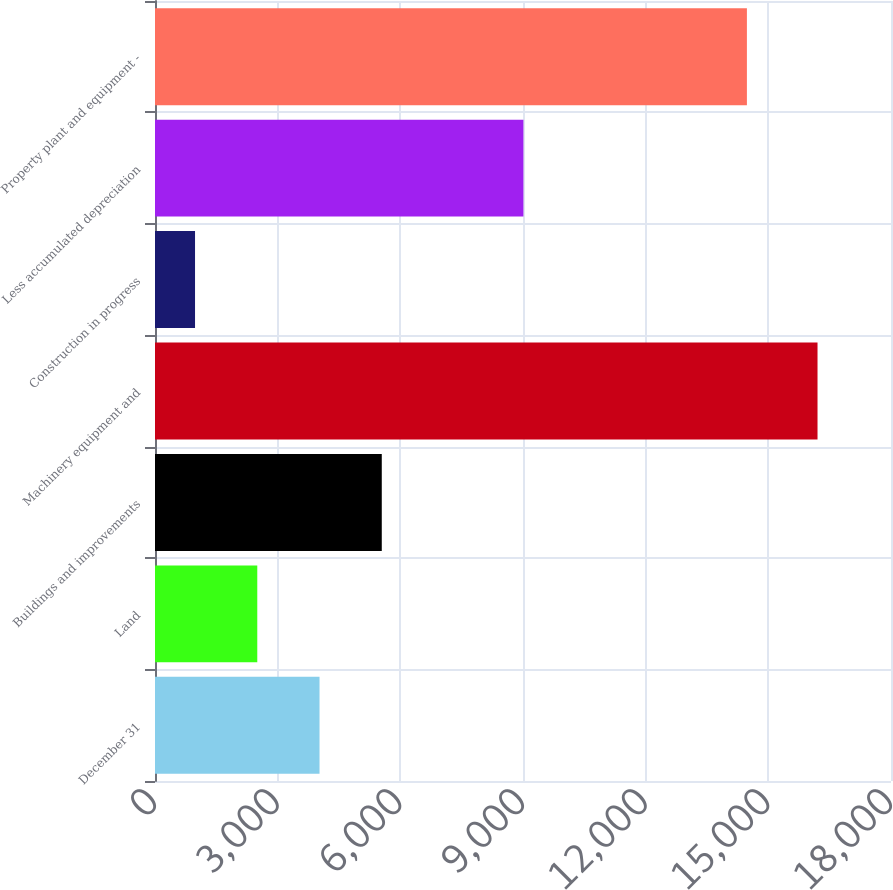Convert chart. <chart><loc_0><loc_0><loc_500><loc_500><bar_chart><fcel>December 31<fcel>Land<fcel>Buildings and improvements<fcel>Machinery equipment and<fcel>Construction in progress<fcel>Less accumulated depreciation<fcel>Property plant and equipment -<nl><fcel>4023.8<fcel>2501.4<fcel>5546.2<fcel>16203<fcel>979<fcel>9010<fcel>14476<nl></chart> 